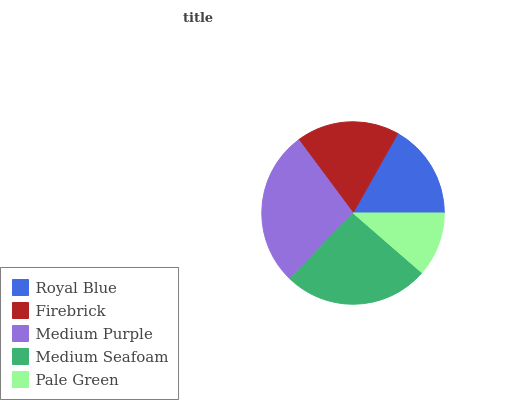Is Pale Green the minimum?
Answer yes or no. Yes. Is Medium Purple the maximum?
Answer yes or no. Yes. Is Firebrick the minimum?
Answer yes or no. No. Is Firebrick the maximum?
Answer yes or no. No. Is Firebrick greater than Royal Blue?
Answer yes or no. Yes. Is Royal Blue less than Firebrick?
Answer yes or no. Yes. Is Royal Blue greater than Firebrick?
Answer yes or no. No. Is Firebrick less than Royal Blue?
Answer yes or no. No. Is Firebrick the high median?
Answer yes or no. Yes. Is Firebrick the low median?
Answer yes or no. Yes. Is Pale Green the high median?
Answer yes or no. No. Is Pale Green the low median?
Answer yes or no. No. 